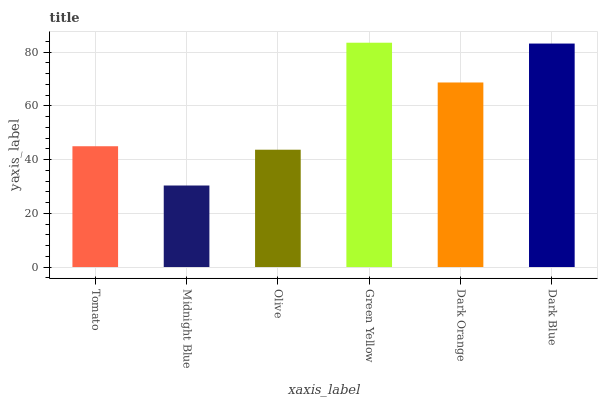Is Midnight Blue the minimum?
Answer yes or no. Yes. Is Green Yellow the maximum?
Answer yes or no. Yes. Is Olive the minimum?
Answer yes or no. No. Is Olive the maximum?
Answer yes or no. No. Is Olive greater than Midnight Blue?
Answer yes or no. Yes. Is Midnight Blue less than Olive?
Answer yes or no. Yes. Is Midnight Blue greater than Olive?
Answer yes or no. No. Is Olive less than Midnight Blue?
Answer yes or no. No. Is Dark Orange the high median?
Answer yes or no. Yes. Is Tomato the low median?
Answer yes or no. Yes. Is Tomato the high median?
Answer yes or no. No. Is Olive the low median?
Answer yes or no. No. 